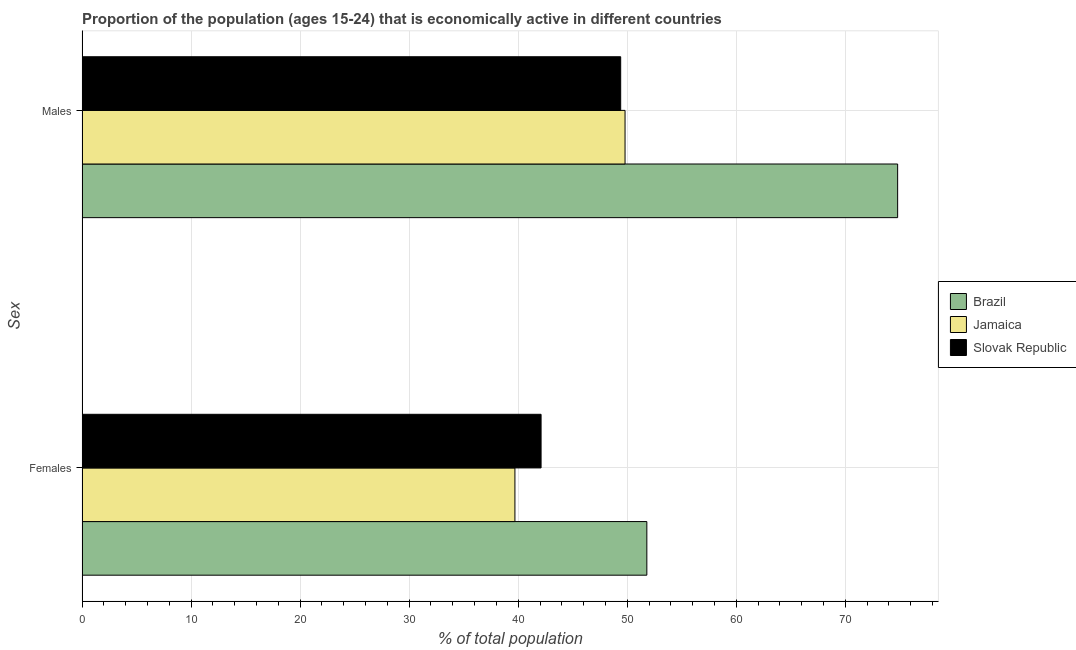How many different coloured bars are there?
Provide a succinct answer. 3. How many groups of bars are there?
Provide a short and direct response. 2. What is the label of the 1st group of bars from the top?
Provide a short and direct response. Males. What is the percentage of economically active female population in Jamaica?
Keep it short and to the point. 39.7. Across all countries, what is the maximum percentage of economically active female population?
Offer a terse response. 51.8. Across all countries, what is the minimum percentage of economically active male population?
Offer a terse response. 49.4. In which country was the percentage of economically active male population maximum?
Provide a short and direct response. Brazil. In which country was the percentage of economically active female population minimum?
Your response must be concise. Jamaica. What is the total percentage of economically active male population in the graph?
Your response must be concise. 174. What is the difference between the percentage of economically active male population in Slovak Republic and that in Jamaica?
Your answer should be very brief. -0.4. What is the difference between the percentage of economically active male population in Brazil and the percentage of economically active female population in Jamaica?
Provide a succinct answer. 35.1. What is the average percentage of economically active female population per country?
Offer a terse response. 44.53. What is the difference between the percentage of economically active female population and percentage of economically active male population in Brazil?
Make the answer very short. -23. In how many countries, is the percentage of economically active male population greater than 34 %?
Offer a very short reply. 3. What is the ratio of the percentage of economically active male population in Jamaica to that in Brazil?
Provide a short and direct response. 0.67. Is the percentage of economically active female population in Slovak Republic less than that in Jamaica?
Offer a terse response. No. What does the 1st bar from the bottom in Females represents?
Offer a very short reply. Brazil. How many bars are there?
Your response must be concise. 6. How many countries are there in the graph?
Make the answer very short. 3. Are the values on the major ticks of X-axis written in scientific E-notation?
Ensure brevity in your answer.  No. Does the graph contain any zero values?
Provide a succinct answer. No. Does the graph contain grids?
Provide a succinct answer. Yes. Where does the legend appear in the graph?
Keep it short and to the point. Center right. How many legend labels are there?
Ensure brevity in your answer.  3. What is the title of the graph?
Ensure brevity in your answer.  Proportion of the population (ages 15-24) that is economically active in different countries. What is the label or title of the X-axis?
Your answer should be very brief. % of total population. What is the label or title of the Y-axis?
Keep it short and to the point. Sex. What is the % of total population in Brazil in Females?
Provide a short and direct response. 51.8. What is the % of total population of Jamaica in Females?
Keep it short and to the point. 39.7. What is the % of total population in Slovak Republic in Females?
Your response must be concise. 42.1. What is the % of total population in Brazil in Males?
Offer a terse response. 74.8. What is the % of total population in Jamaica in Males?
Provide a succinct answer. 49.8. What is the % of total population in Slovak Republic in Males?
Provide a short and direct response. 49.4. Across all Sex, what is the maximum % of total population in Brazil?
Provide a short and direct response. 74.8. Across all Sex, what is the maximum % of total population in Jamaica?
Your response must be concise. 49.8. Across all Sex, what is the maximum % of total population in Slovak Republic?
Offer a very short reply. 49.4. Across all Sex, what is the minimum % of total population of Brazil?
Provide a succinct answer. 51.8. Across all Sex, what is the minimum % of total population of Jamaica?
Offer a very short reply. 39.7. Across all Sex, what is the minimum % of total population of Slovak Republic?
Offer a very short reply. 42.1. What is the total % of total population of Brazil in the graph?
Keep it short and to the point. 126.6. What is the total % of total population of Jamaica in the graph?
Give a very brief answer. 89.5. What is the total % of total population in Slovak Republic in the graph?
Make the answer very short. 91.5. What is the difference between the % of total population of Brazil in Females and that in Males?
Offer a terse response. -23. What is the difference between the % of total population in Brazil in Females and the % of total population in Slovak Republic in Males?
Keep it short and to the point. 2.4. What is the average % of total population in Brazil per Sex?
Give a very brief answer. 63.3. What is the average % of total population of Jamaica per Sex?
Keep it short and to the point. 44.75. What is the average % of total population in Slovak Republic per Sex?
Your answer should be very brief. 45.75. What is the difference between the % of total population in Brazil and % of total population in Slovak Republic in Females?
Provide a short and direct response. 9.7. What is the difference between the % of total population of Jamaica and % of total population of Slovak Republic in Females?
Keep it short and to the point. -2.4. What is the difference between the % of total population of Brazil and % of total population of Slovak Republic in Males?
Your answer should be very brief. 25.4. What is the difference between the % of total population in Jamaica and % of total population in Slovak Republic in Males?
Offer a terse response. 0.4. What is the ratio of the % of total population of Brazil in Females to that in Males?
Offer a very short reply. 0.69. What is the ratio of the % of total population in Jamaica in Females to that in Males?
Keep it short and to the point. 0.8. What is the ratio of the % of total population of Slovak Republic in Females to that in Males?
Make the answer very short. 0.85. What is the difference between the highest and the second highest % of total population of Jamaica?
Your response must be concise. 10.1. What is the difference between the highest and the second highest % of total population of Slovak Republic?
Keep it short and to the point. 7.3. 